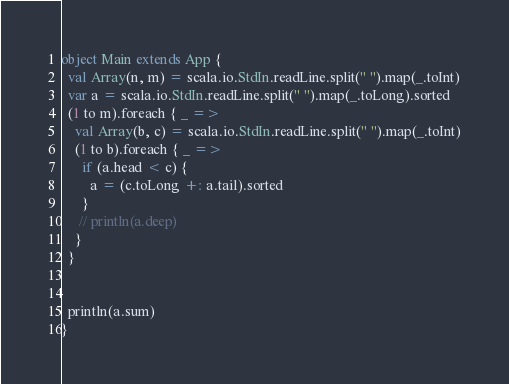Convert code to text. <code><loc_0><loc_0><loc_500><loc_500><_Scala_>
object Main extends App {
  val Array(n, m) = scala.io.StdIn.readLine.split(" ").map(_.toInt)
  var a = scala.io.StdIn.readLine.split(" ").map(_.toLong).sorted
  (1 to m).foreach { _ =>
    val Array(b, c) = scala.io.StdIn.readLine.split(" ").map(_.toInt)
    (1 to b).foreach { _ =>
      if (a.head < c) {
        a = (c.toLong +: a.tail).sorted
      }
     // println(a.deep)
    }
  }


  println(a.sum)
}</code> 